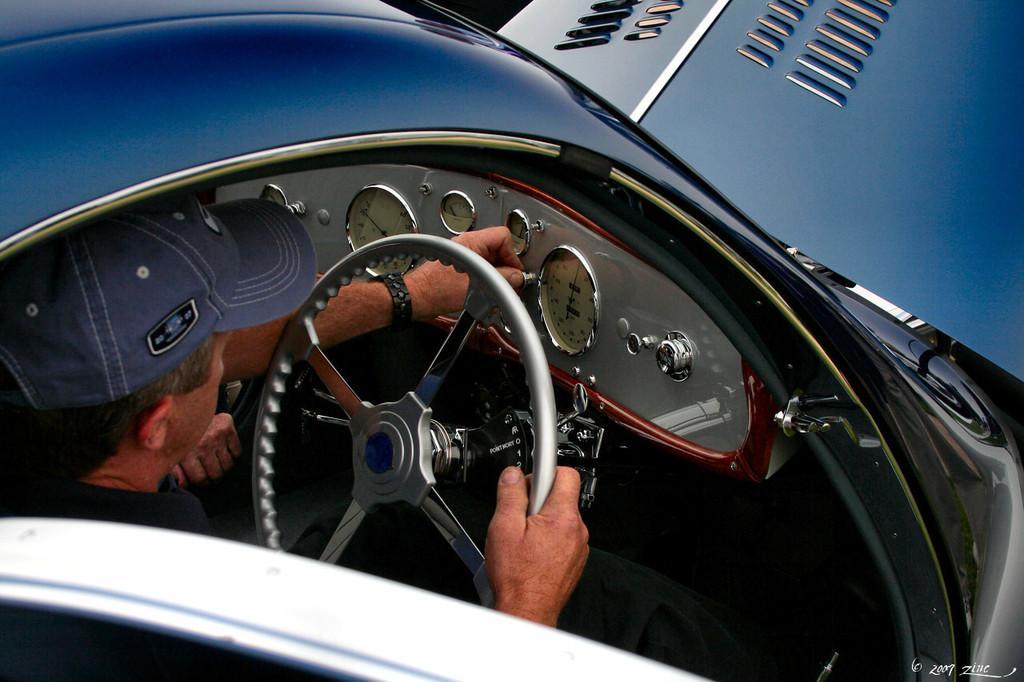Could you give a brief overview of what you see in this image? In the image we can see there is a man in a car he is holding a steering wheel and wearing a blue colour cap. 